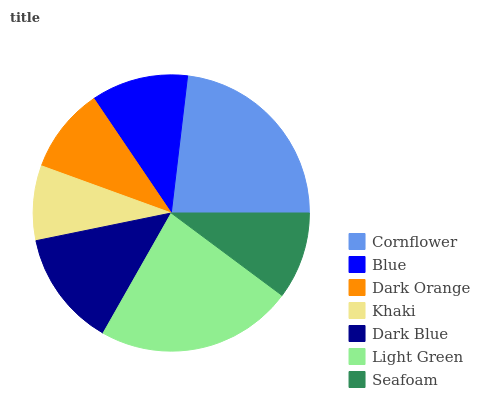Is Khaki the minimum?
Answer yes or no. Yes. Is Cornflower the maximum?
Answer yes or no. Yes. Is Blue the minimum?
Answer yes or no. No. Is Blue the maximum?
Answer yes or no. No. Is Cornflower greater than Blue?
Answer yes or no. Yes. Is Blue less than Cornflower?
Answer yes or no. Yes. Is Blue greater than Cornflower?
Answer yes or no. No. Is Cornflower less than Blue?
Answer yes or no. No. Is Blue the high median?
Answer yes or no. Yes. Is Blue the low median?
Answer yes or no. Yes. Is Seafoam the high median?
Answer yes or no. No. Is Khaki the low median?
Answer yes or no. No. 